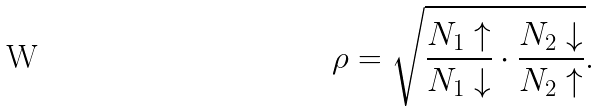Convert formula to latex. <formula><loc_0><loc_0><loc_500><loc_500>\rho = \sqrt { \frac { N _ { 1 } \uparrow } { N _ { 1 } \downarrow } \cdot \frac { N _ { 2 } \downarrow } { N _ { 2 } \uparrow } } .</formula> 